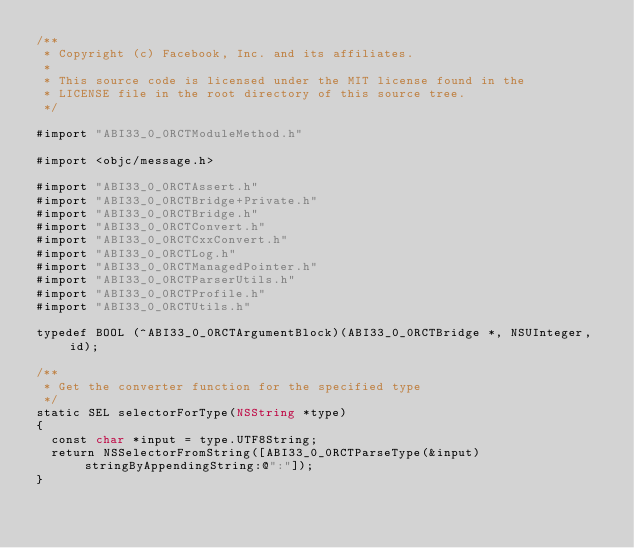Convert code to text. <code><loc_0><loc_0><loc_500><loc_500><_ObjectiveC_>/**
 * Copyright (c) Facebook, Inc. and its affiliates.
 *
 * This source code is licensed under the MIT license found in the
 * LICENSE file in the root directory of this source tree.
 */

#import "ABI33_0_0RCTModuleMethod.h"

#import <objc/message.h>

#import "ABI33_0_0RCTAssert.h"
#import "ABI33_0_0RCTBridge+Private.h"
#import "ABI33_0_0RCTBridge.h"
#import "ABI33_0_0RCTConvert.h"
#import "ABI33_0_0RCTCxxConvert.h"
#import "ABI33_0_0RCTLog.h"
#import "ABI33_0_0RCTManagedPointer.h"
#import "ABI33_0_0RCTParserUtils.h"
#import "ABI33_0_0RCTProfile.h"
#import "ABI33_0_0RCTUtils.h"

typedef BOOL (^ABI33_0_0RCTArgumentBlock)(ABI33_0_0RCTBridge *, NSUInteger, id);

/**
 * Get the converter function for the specified type
 */
static SEL selectorForType(NSString *type)
{
  const char *input = type.UTF8String;
  return NSSelectorFromString([ABI33_0_0RCTParseType(&input) stringByAppendingString:@":"]);
}
</code> 